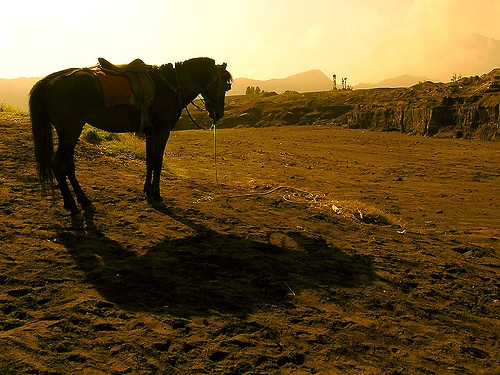Describe the objects in this image and their specific colors. I can see a horse in white, black, maroon, and olive tones in this image. 